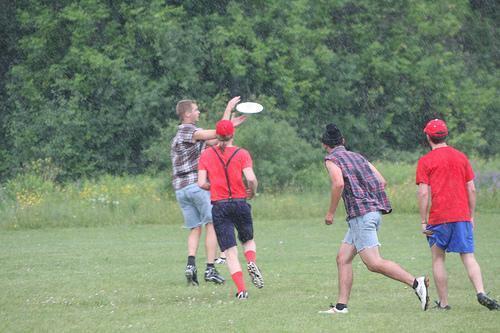How many people are there?
Give a very brief answer. 4. How many people have on hats?
Give a very brief answer. 2. How many frisbys are there?
Give a very brief answer. 1. 